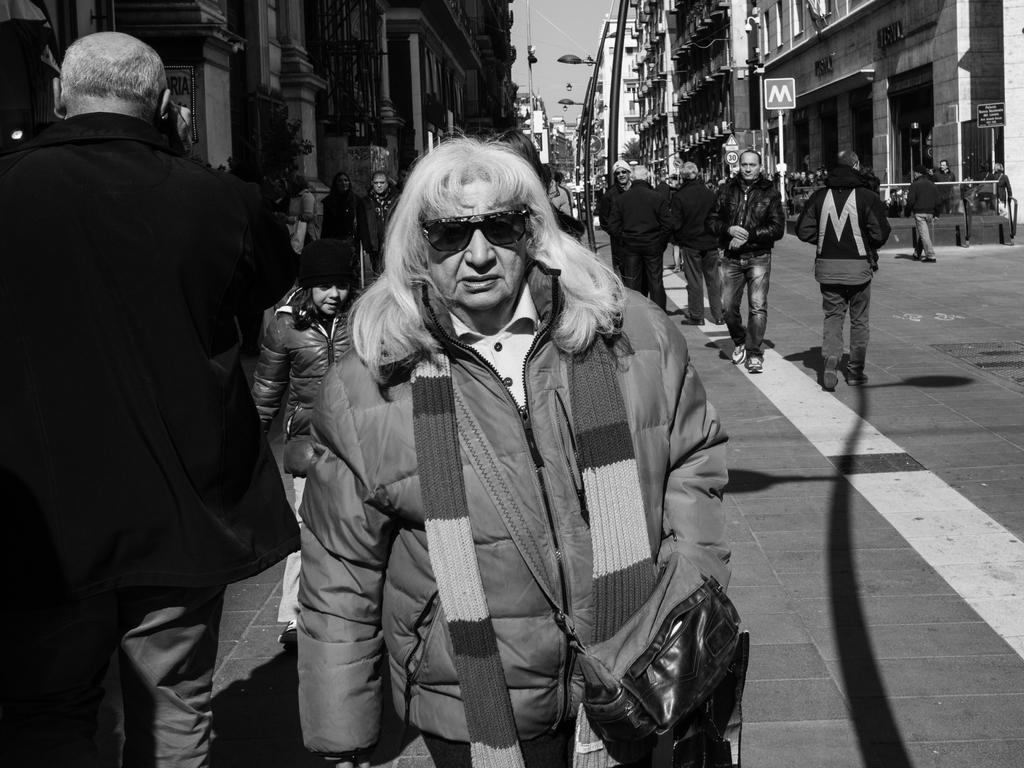What is the color scheme of the image? The image is black and white. What can be seen happening on the road in the image? There are people walking on the road. What structures are present on either side of the road? There are buildings on either side of the road. What is visible above the road in the image? The sky is visible above the road. Can you hear the people in the image laughing while walking? There is no sound in the image, so it is not possible to determine if the people are laughing or not. 